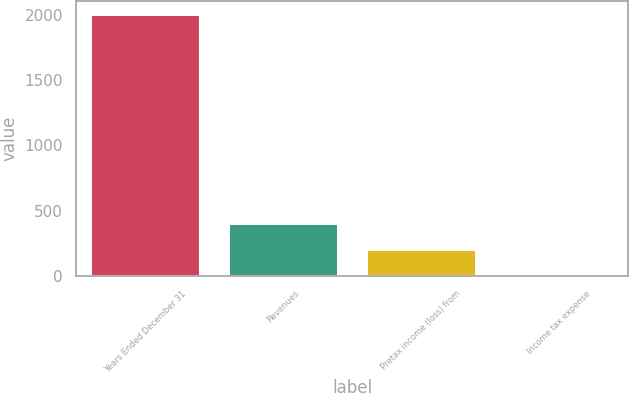<chart> <loc_0><loc_0><loc_500><loc_500><bar_chart><fcel>Years Ended December 31<fcel>Revenues<fcel>Pretax income (loss) from<fcel>Income tax expense<nl><fcel>2008<fcel>402.4<fcel>201.7<fcel>1<nl></chart> 